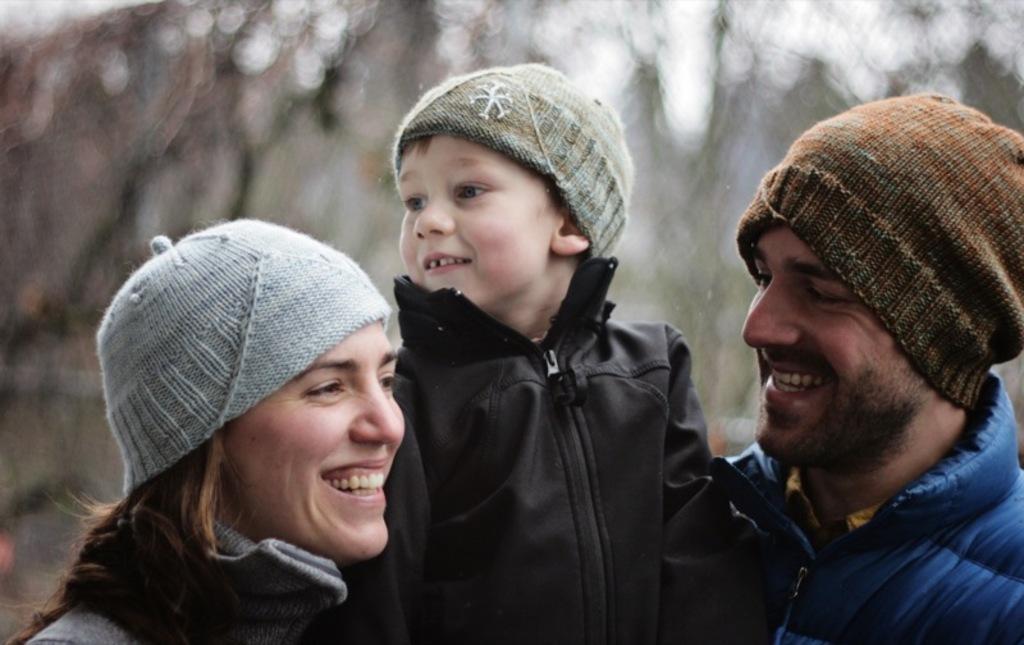In one or two sentences, can you explain what this image depicts? In this image I can see three persons. The person at right wearing blue jacket, brown cap, the person in the middle wearing black jacket and the person at left wearing gray color dress. Background the sky is in white color. 